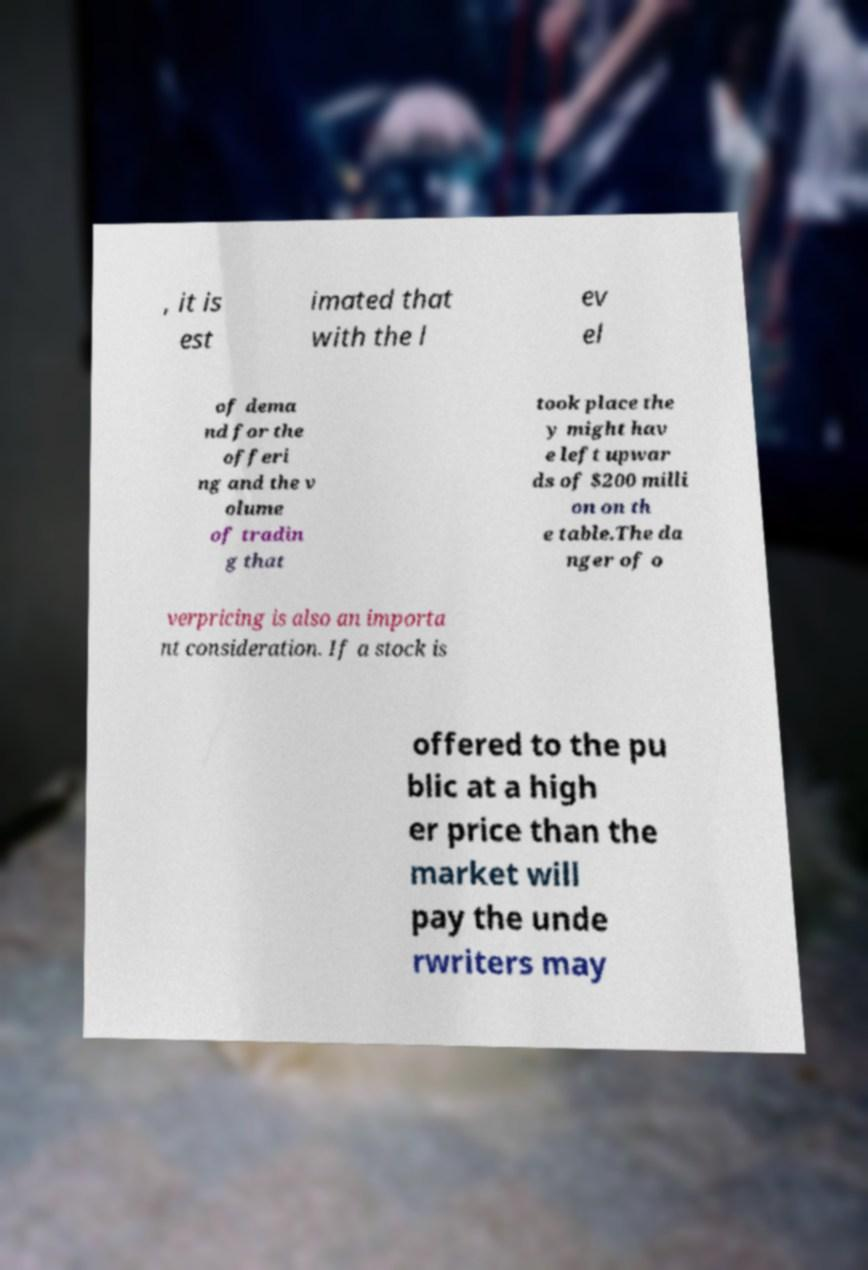Please identify and transcribe the text found in this image. , it is est imated that with the l ev el of dema nd for the offeri ng and the v olume of tradin g that took place the y might hav e left upwar ds of $200 milli on on th e table.The da nger of o verpricing is also an importa nt consideration. If a stock is offered to the pu blic at a high er price than the market will pay the unde rwriters may 